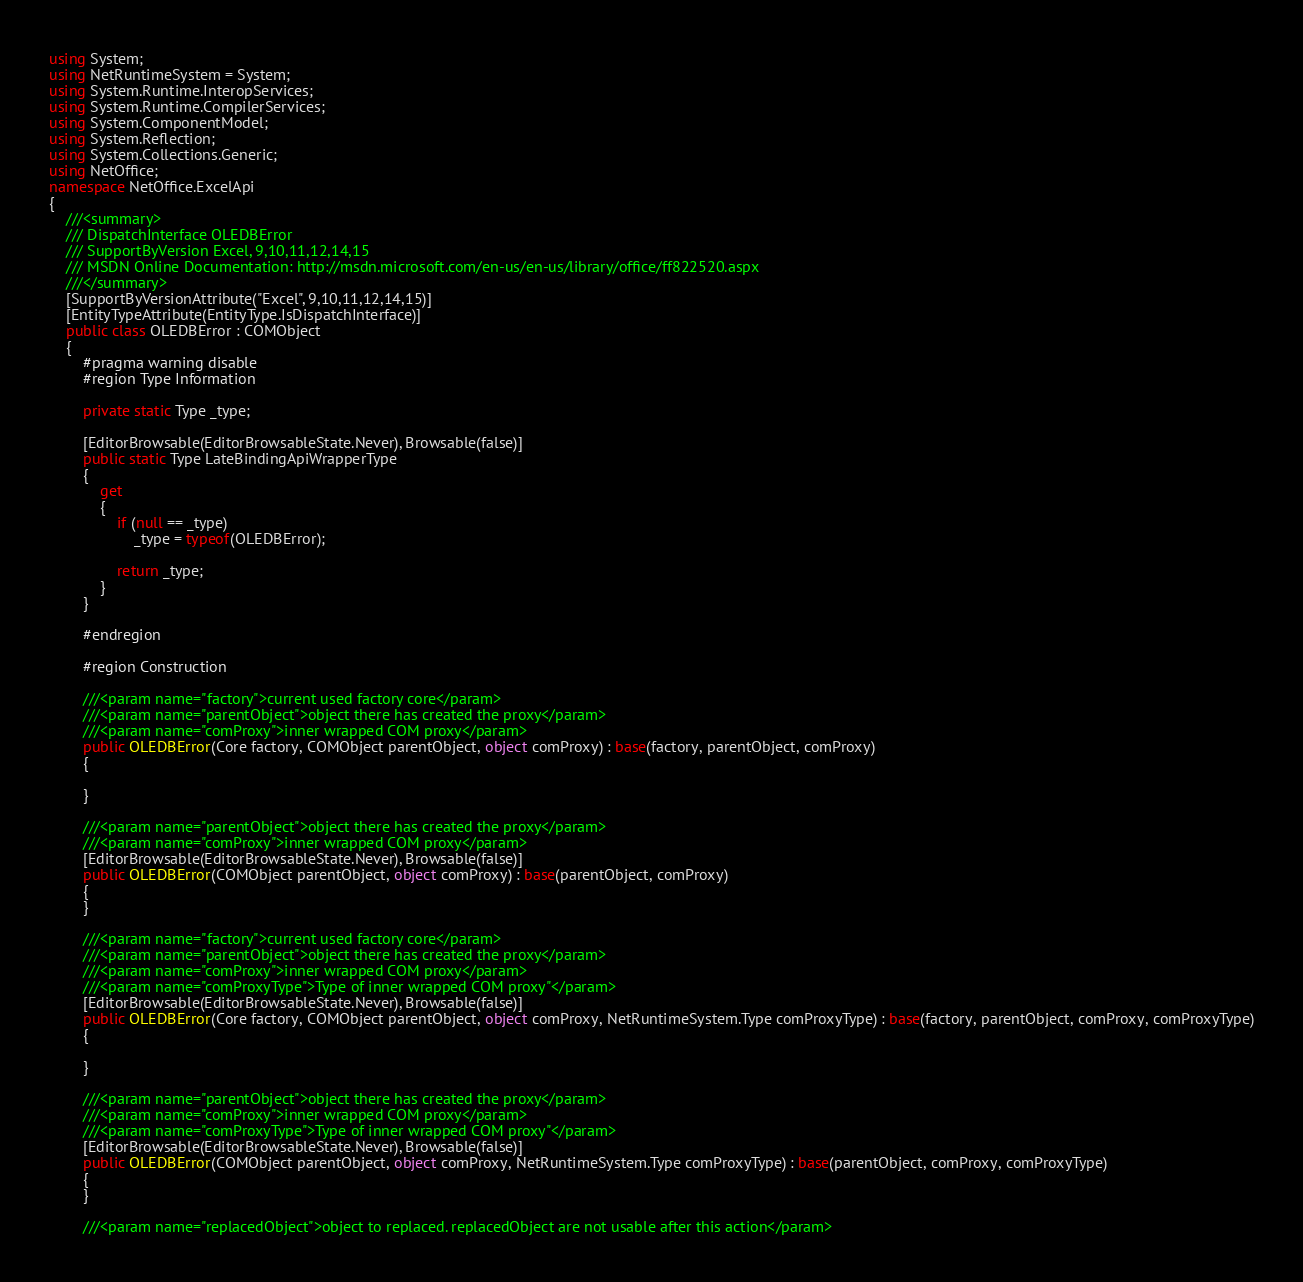Convert code to text. <code><loc_0><loc_0><loc_500><loc_500><_C#_>using System;
using NetRuntimeSystem = System;
using System.Runtime.InteropServices;
using System.Runtime.CompilerServices;
using System.ComponentModel;
using System.Reflection;
using System.Collections.Generic;
using NetOffice;
namespace NetOffice.ExcelApi
{
	///<summary>
	/// DispatchInterface OLEDBError 
	/// SupportByVersion Excel, 9,10,11,12,14,15
	/// MSDN Online Documentation: http://msdn.microsoft.com/en-us/en-us/library/office/ff822520.aspx
	///</summary>
	[SupportByVersionAttribute("Excel", 9,10,11,12,14,15)]
	[EntityTypeAttribute(EntityType.IsDispatchInterface)]
	public class OLEDBError : COMObject
	{
		#pragma warning disable
		#region Type Information

        private static Type _type;

		[EditorBrowsable(EditorBrowsableState.Never), Browsable(false)]
        public static Type LateBindingApiWrapperType
        {
            get
            {
                if (null == _type)
                    _type = typeof(OLEDBError);
                    
                return _type;
            }
        }
        
        #endregion
        
		#region Construction

		///<param name="factory">current used factory core</param>
		///<param name="parentObject">object there has created the proxy</param>
        ///<param name="comProxy">inner wrapped COM proxy</param>
		public OLEDBError(Core factory, COMObject parentObject, object comProxy) : base(factory, parentObject, comProxy)
		{
			
		}

        ///<param name="parentObject">object there has created the proxy</param>
        ///<param name="comProxy">inner wrapped COM proxy</param>
        [EditorBrowsable(EditorBrowsableState.Never), Browsable(false)]
		public OLEDBError(COMObject parentObject, object comProxy) : base(parentObject, comProxy)
		{
		}
		
		///<param name="factory">current used factory core</param>
		///<param name="parentObject">object there has created the proxy</param>
        ///<param name="comProxy">inner wrapped COM proxy</param>
        ///<param name="comProxyType">Type of inner wrapped COM proxy"</param>
		[EditorBrowsable(EditorBrowsableState.Never), Browsable(false)]
		public OLEDBError(Core factory, COMObject parentObject, object comProxy, NetRuntimeSystem.Type comProxyType) : base(factory, parentObject, comProxy, comProxyType)
		{

		}

		///<param name="parentObject">object there has created the proxy</param>
        ///<param name="comProxy">inner wrapped COM proxy</param>
        ///<param name="comProxyType">Type of inner wrapped COM proxy"</param>
        [EditorBrowsable(EditorBrowsableState.Never), Browsable(false)]
		public OLEDBError(COMObject parentObject, object comProxy, NetRuntimeSystem.Type comProxyType) : base(parentObject, comProxy, comProxyType)
		{
		}
		
		///<param name="replacedObject">object to replaced. replacedObject are not usable after this action</param></code> 